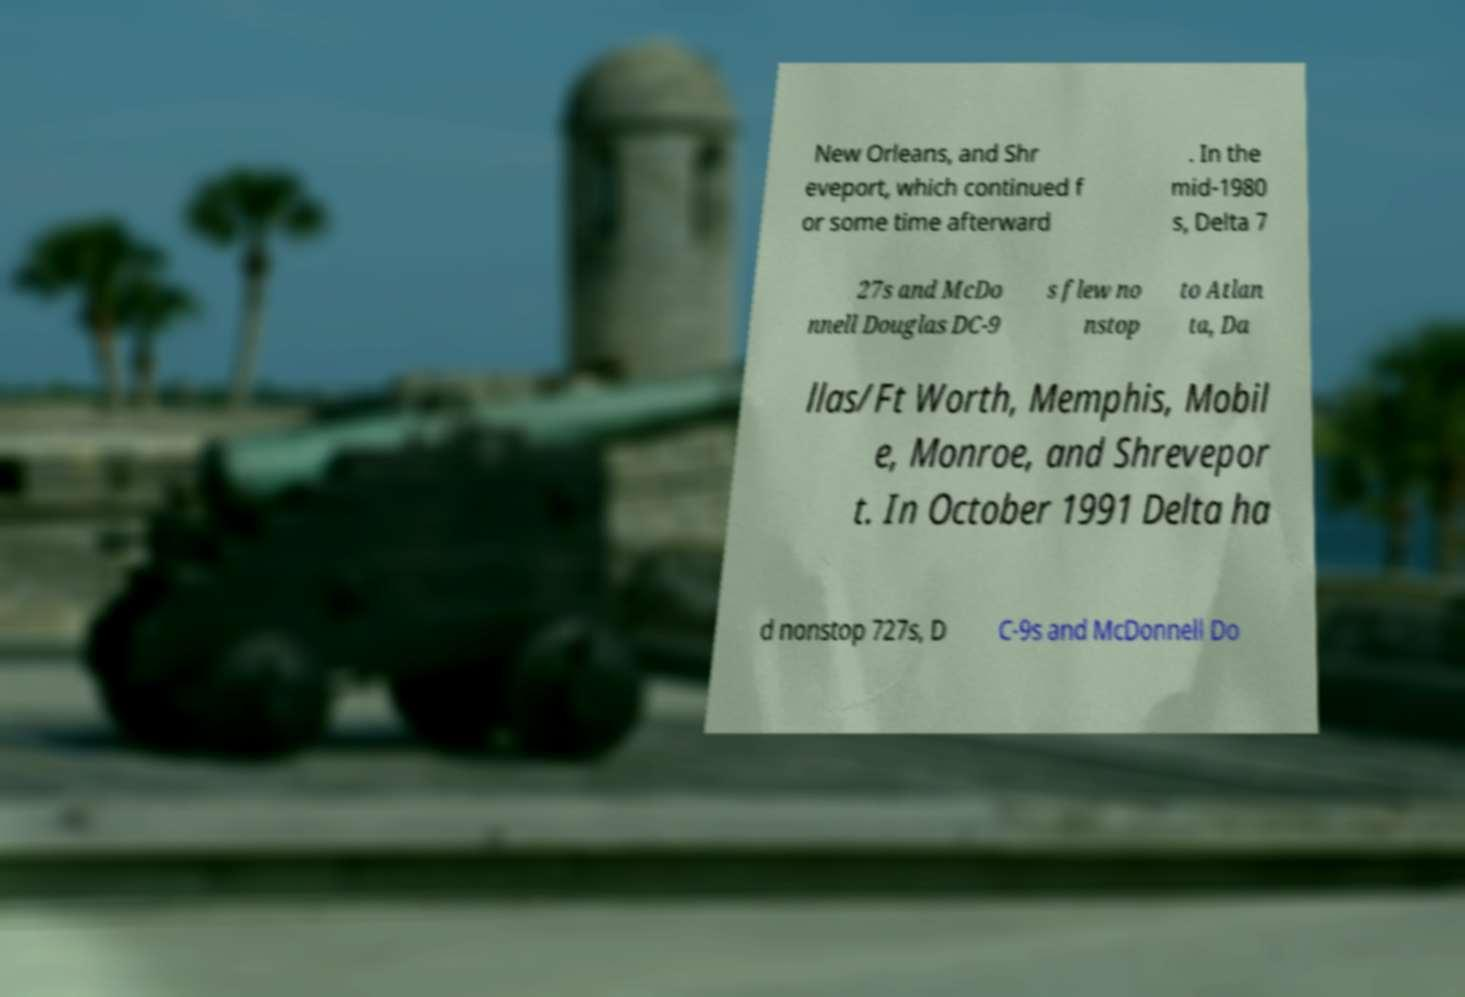Could you assist in decoding the text presented in this image and type it out clearly? New Orleans, and Shr eveport, which continued f or some time afterward . In the mid-1980 s, Delta 7 27s and McDo nnell Douglas DC-9 s flew no nstop to Atlan ta, Da llas/Ft Worth, Memphis, Mobil e, Monroe, and Shrevepor t. In October 1991 Delta ha d nonstop 727s, D C-9s and McDonnell Do 